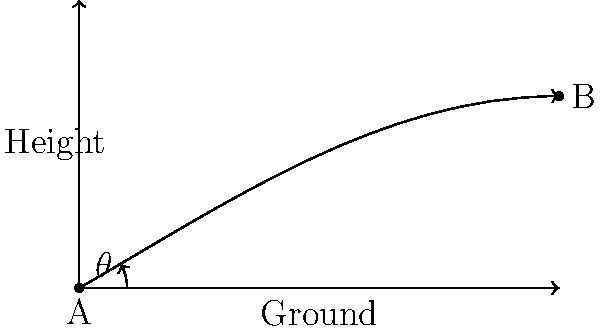As a tennis legend known for your innovative playing style, you understand the importance of serve trajectory. In the diagram, a tennis serve is represented by the curved path from point A to point B. If the initial angle of the serve with respect to the ground is $\theta = 30°$, and the serve travels a horizontal distance of 100 feet, what is the approximate height of the ball at point B, assuming no air resistance and a constant gravitational acceleration of 32 ft/s²? To solve this problem, we'll use the equations of projectile motion:

1) The time of flight can be calculated using the horizontal distance:
   $x = v_0 \cos(\theta) \cdot t$
   $100 = v_0 \cos(30°) \cdot t$

2) The vertical displacement is given by:
   $y = v_0 \sin(\theta) \cdot t - \frac{1}{2}gt^2$

3) We don't know the initial velocity $v_0$, but we can eliminate it using the two equations:

   From (1): $v_0 = \frac{100}{t \cos(30°)}$

   Substituting into (2):
   $y = \frac{100}{t \cos(30°)} \sin(30°) \cdot t - \frac{1}{2}(32)t^2$

4) Simplify:
   $y = 100 \tan(30°) - 16t^2$
   $y = 100 \cdot \frac{1}{\sqrt{3}} - 16t^2$

5) Now, we need to find t. From (1):
   $t = \frac{100}{v_0 \cos(30°)}$

6) The average horizontal velocity is $\frac{100}{t}$, which equals $v_0 \cos(30°)$

7) Therefore, $t = \frac{100}{100/t} = t$

8) Solving: $t = \sqrt{\frac{100}{16g}} = \sqrt{\frac{100}{16(32)}} = \sqrt{\frac{25}{128}} \approx 0.44$ seconds

9) Plugging this back into our equation for y:
   $y = 100 \cdot \frac{1}{\sqrt{3}} - 16(0.44)^2$
   $y \approx 57.74 - 3.10 = 54.64$ feet

Therefore, the height of the ball at point B is approximately 54.64 feet.
Answer: 54.64 feet 